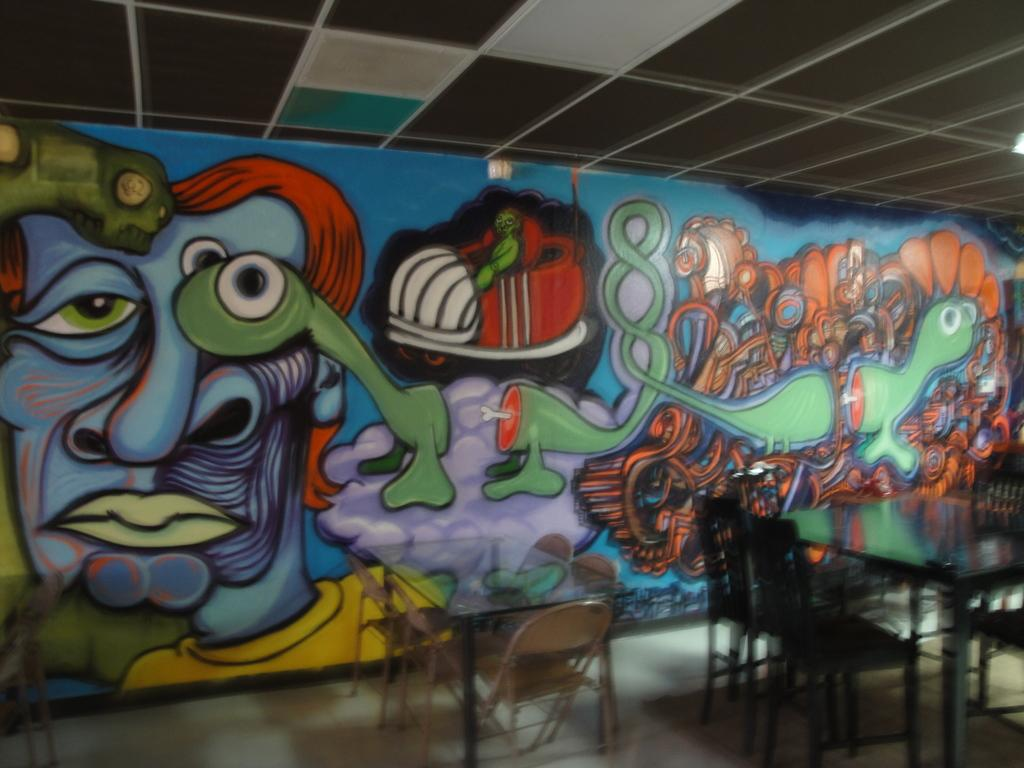What type of furniture is present in the image? There are tables and chairs in the image. What can be seen on the wall in the image? There is a painting on the wall in the image. How much fuel is required to power the table in the image? There is no fuel required to power the table in the image, as tables do not require fuel to function. 